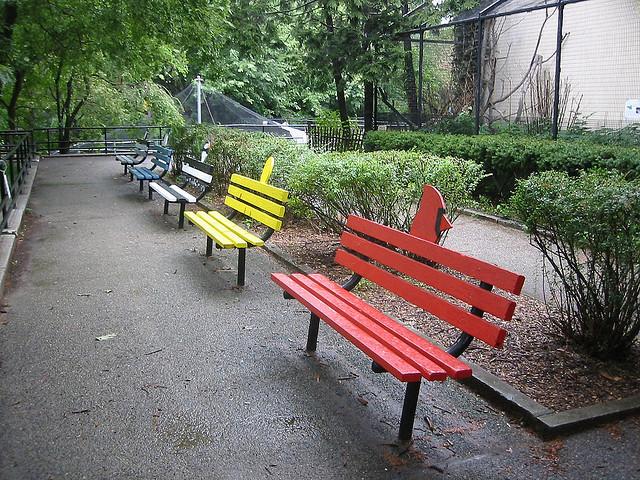For beauty purposes?
Give a very brief answer. Yes. What color is the second furthest away bench?
Answer briefly. Blue. Why are all the benches different colors?
Concise answer only. Art. 